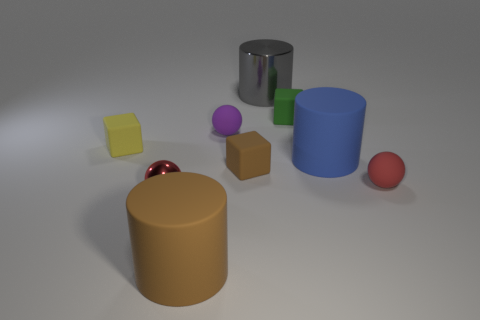Does the rubber sphere to the right of the brown matte block have the same color as the small shiny ball?
Your answer should be compact. Yes. There is a small block to the left of the big brown matte object; what number of yellow objects are behind it?
Your answer should be very brief. 0. Are there any other things that have the same shape as the green rubber thing?
Your answer should be very brief. Yes. Does the matte ball that is in front of the small yellow object have the same color as the metal object in front of the gray metallic cylinder?
Offer a terse response. Yes. Are there fewer cyan cylinders than big rubber cylinders?
Your response must be concise. Yes. There is a tiny matte thing that is on the left side of the rubber cylinder in front of the small metallic object; what shape is it?
Your answer should be compact. Cube. There is a brown thing that is behind the brown object in front of the small rubber object that is right of the large blue rubber cylinder; what shape is it?
Keep it short and to the point. Cube. What number of things are metallic things that are in front of the red rubber ball or brown matte things that are right of the brown cylinder?
Make the answer very short. 2. There is a green cube; does it have the same size as the brown object in front of the red metallic object?
Keep it short and to the point. No. Is the material of the sphere that is behind the small brown thing the same as the small red sphere that is right of the small red metal thing?
Provide a short and direct response. Yes. 